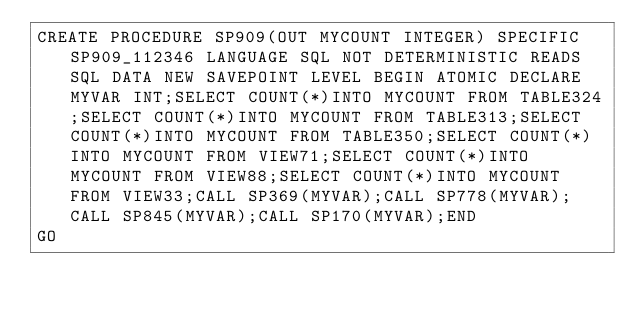<code> <loc_0><loc_0><loc_500><loc_500><_SQL_>CREATE PROCEDURE SP909(OUT MYCOUNT INTEGER) SPECIFIC SP909_112346 LANGUAGE SQL NOT DETERMINISTIC READS SQL DATA NEW SAVEPOINT LEVEL BEGIN ATOMIC DECLARE MYVAR INT;SELECT COUNT(*)INTO MYCOUNT FROM TABLE324;SELECT COUNT(*)INTO MYCOUNT FROM TABLE313;SELECT COUNT(*)INTO MYCOUNT FROM TABLE350;SELECT COUNT(*)INTO MYCOUNT FROM VIEW71;SELECT COUNT(*)INTO MYCOUNT FROM VIEW88;SELECT COUNT(*)INTO MYCOUNT FROM VIEW33;CALL SP369(MYVAR);CALL SP778(MYVAR);CALL SP845(MYVAR);CALL SP170(MYVAR);END
GO</code> 